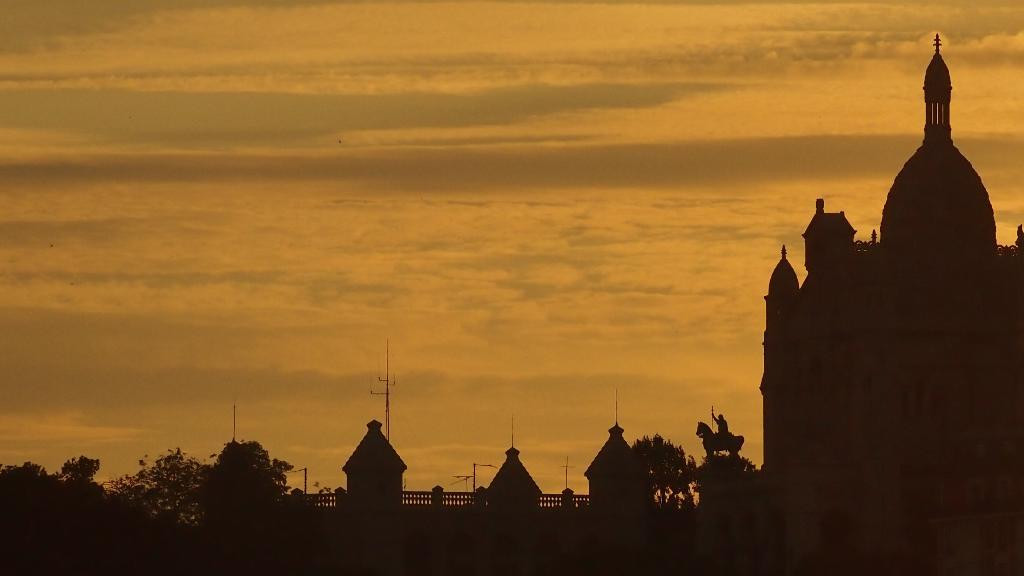What type of structures can be seen in the image? There are buildings in the image. What other object is present in the image besides the buildings? There is a statue in the image. Are there any other man-made objects visible in the image? Yes, there is a pole and railing in the image. What type of natural elements can be seen in the image? There are trees in the image. What is visible at the top of the image? The sky is visible at the top of the image. Can you tell me how many grapes are hanging from the pole in the image? There are no grapes present in the image; the pole is not associated with any grapes. What type of carriage is parked near the statue in the image? There is no carriage present in the image; only the statue, buildings, pole, railing, trees, and sky are visible. 